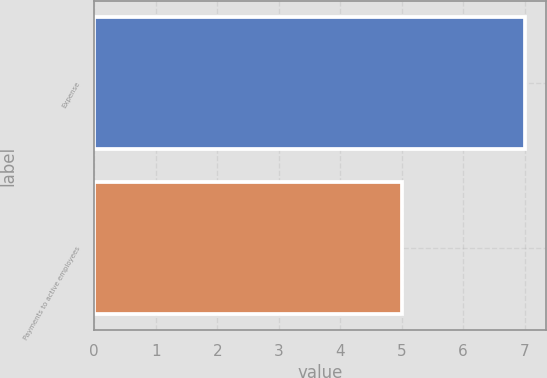Convert chart. <chart><loc_0><loc_0><loc_500><loc_500><bar_chart><fcel>Expense<fcel>Payments to active employees<nl><fcel>7<fcel>5<nl></chart> 